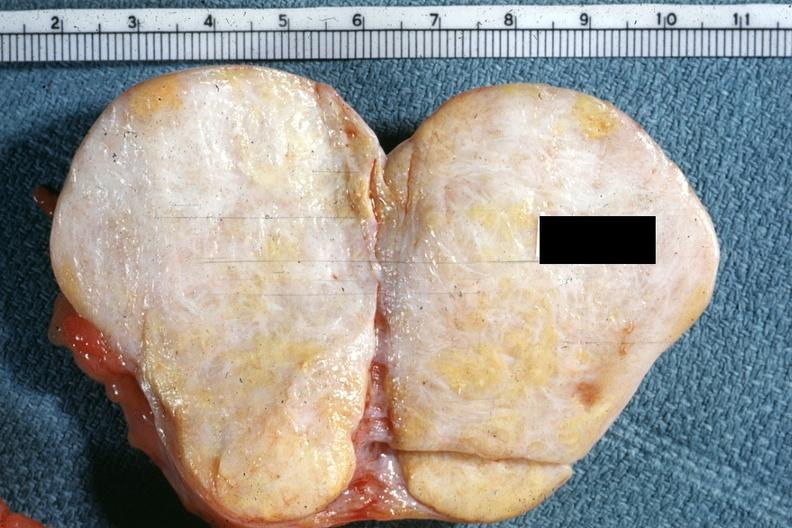what is present?
Answer the question using a single word or phrase. Thecoma 